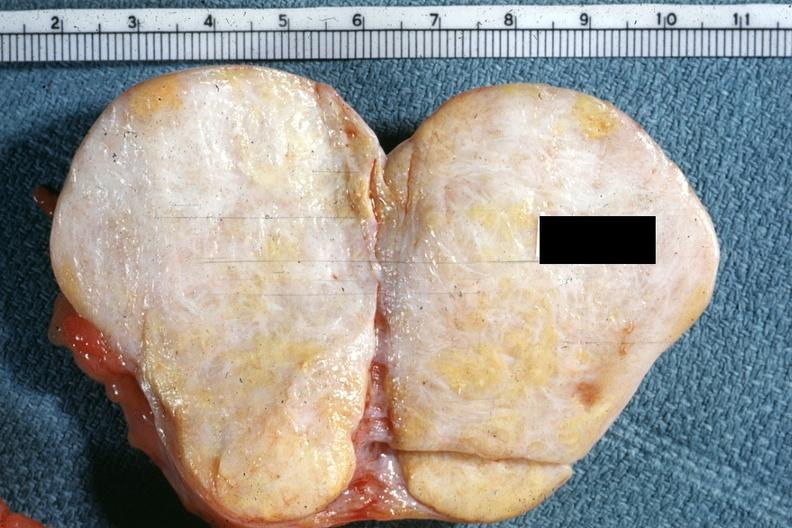what is present?
Answer the question using a single word or phrase. Thecoma 